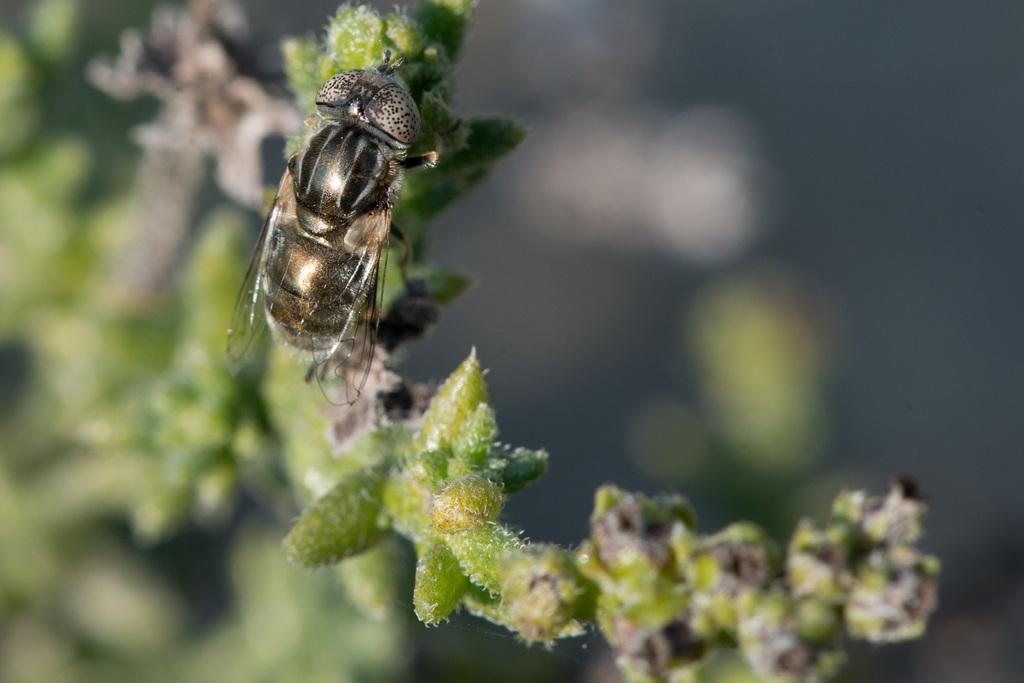What is the main subject in the center of the image? There is a plant in the center of the image. Is there anything else on the plant? Yes, there is an insect on the plant. Can you describe the background of the image? The background of the image is blurred. What is the opinion of the downtown area in the image? There is no downtown area present in the image, so it is not possible to determine an opinion about it. 